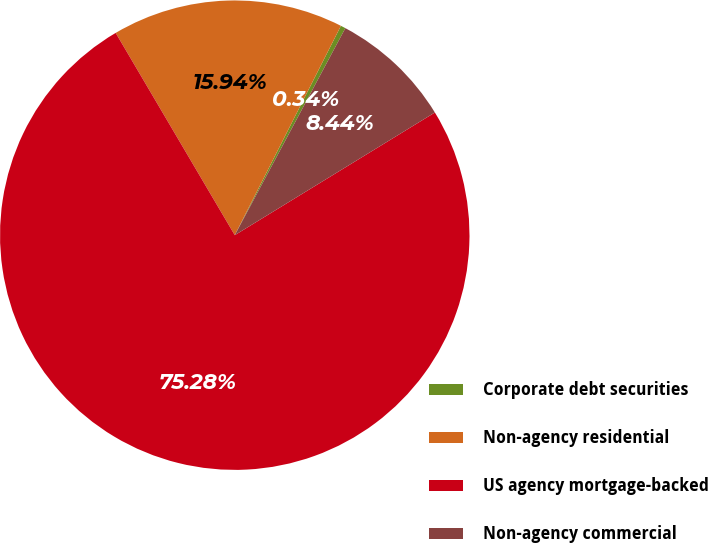Convert chart to OTSL. <chart><loc_0><loc_0><loc_500><loc_500><pie_chart><fcel>Corporate debt securities<fcel>Non-agency residential<fcel>US agency mortgage-backed<fcel>Non-agency commercial<nl><fcel>0.34%<fcel>15.94%<fcel>75.29%<fcel>8.44%<nl></chart> 